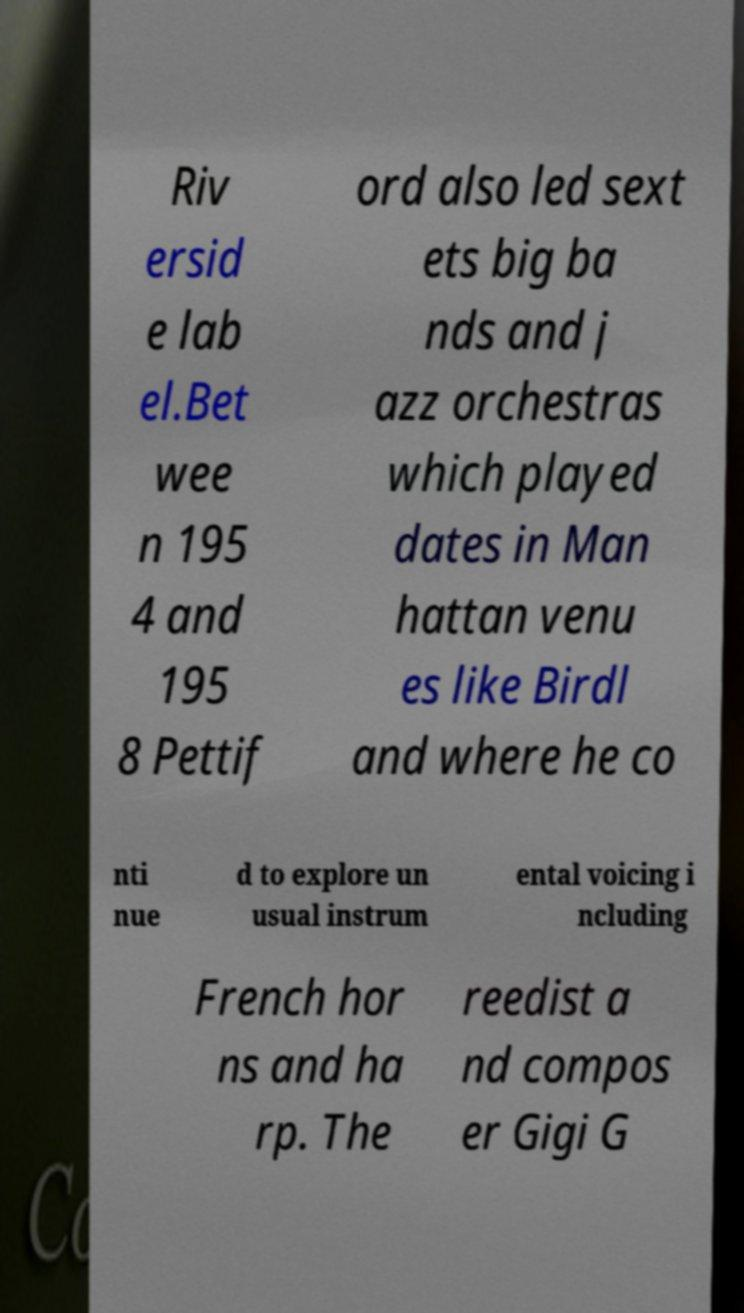What messages or text are displayed in this image? I need them in a readable, typed format. Riv ersid e lab el.Bet wee n 195 4 and 195 8 Pettif ord also led sext ets big ba nds and j azz orchestras which played dates in Man hattan venu es like Birdl and where he co nti nue d to explore un usual instrum ental voicing i ncluding French hor ns and ha rp. The reedist a nd compos er Gigi G 